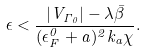Convert formula to latex. <formula><loc_0><loc_0><loc_500><loc_500>\epsilon < \frac { | V _ { \Gamma _ { 0 } } | - \lambda \bar { \beta } } { ( \epsilon _ { F } ^ { 0 } + a ) ^ { 2 } k _ { a } \chi } .</formula> 